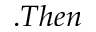<formula> <loc_0><loc_0><loc_500><loc_500>. T h e n</formula> 